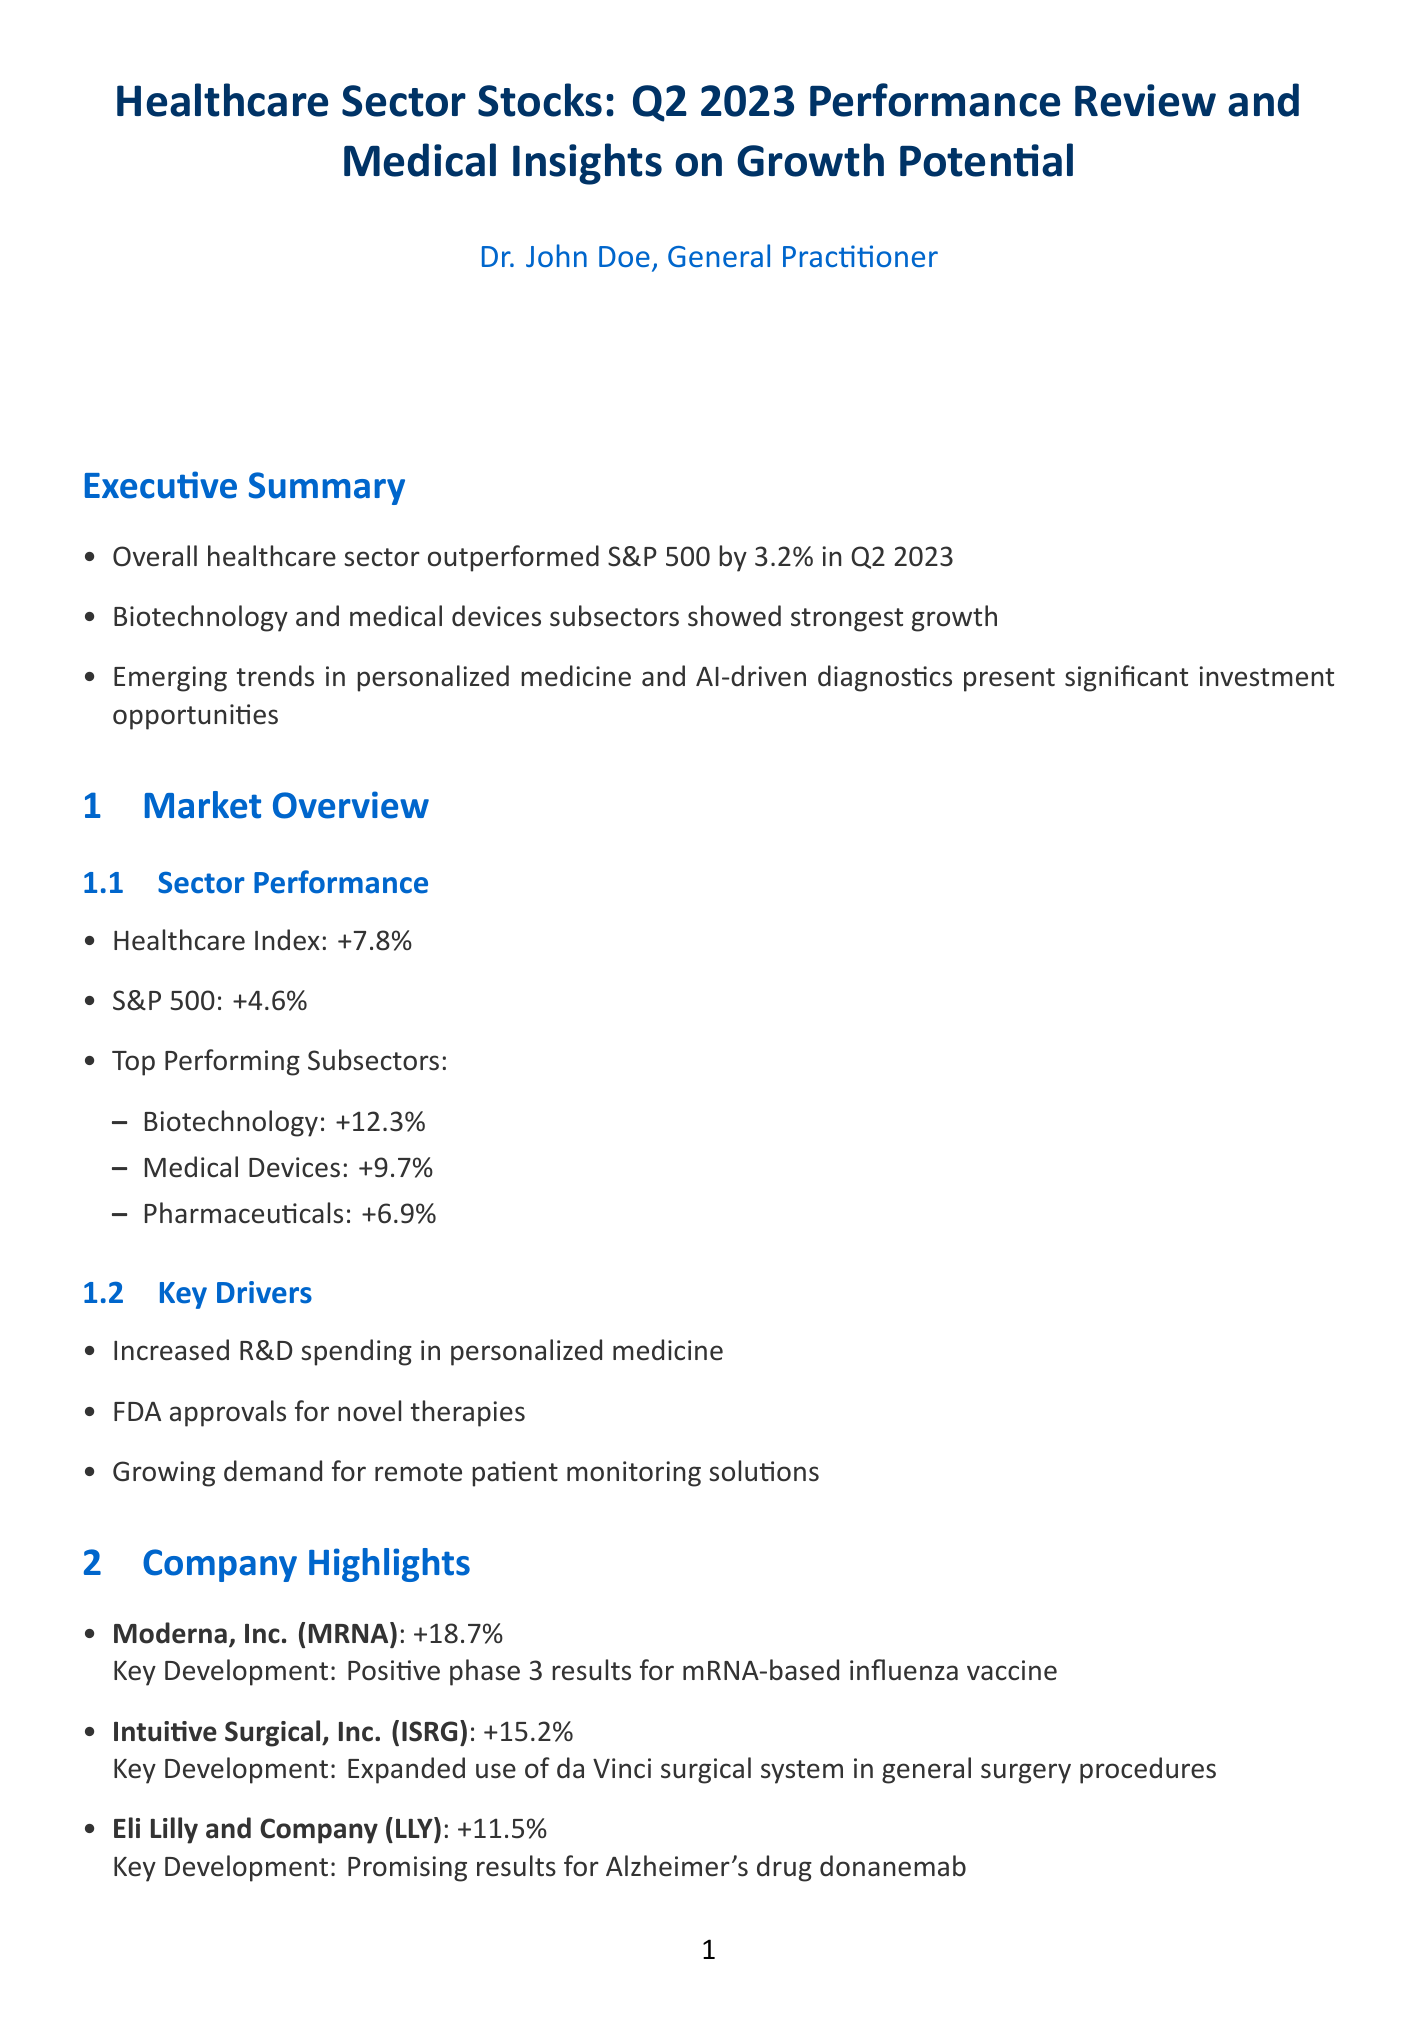what was the healthcare index performance in Q2 2023? The healthcare index performance is stated as +7.8% in Q2 2023.
Answer: +7.8% which subsector had the highest performance? The document mentions that the biotechnology subsector had the highest performance at +12.3%.
Answer: Biotechnology: +12.3% what is one of the trends mentioned in the medical insights? One trend mentioned is "Gene therapy advancements."
Answer: Gene therapy advancements what is the key development for Moderna, Inc.? The document notes that the key development for Moderna is positive phase 3 results for mRNA-based influenza vaccine.
Answer: Positive phase 3 results for mRNA-based influenza vaccine which regulatory development is highlighted? The document states that the FDA's Accelerated Approval Program is under scrutiny.
Answer: FDA's Accelerated Approval Program how many companies are positioned well in the area of precision oncology? The document lists three companies positioned well: Guardant Health, Exact Sciences, and Myriad Genetics.
Answer: 3 what is the potential impact of AI in medical imaging? It states that the potential impact is improved early detection of cancers and neurological disorders.
Answer: Improved early detection of cancers and neurological disorders what investment strategy is suggested in the conclusion? The document suggests considering a balanced approach with exposure to both established players and innovative startups in high-growth areas.
Answer: Balanced approach with exposure to both established players and innovative startups 